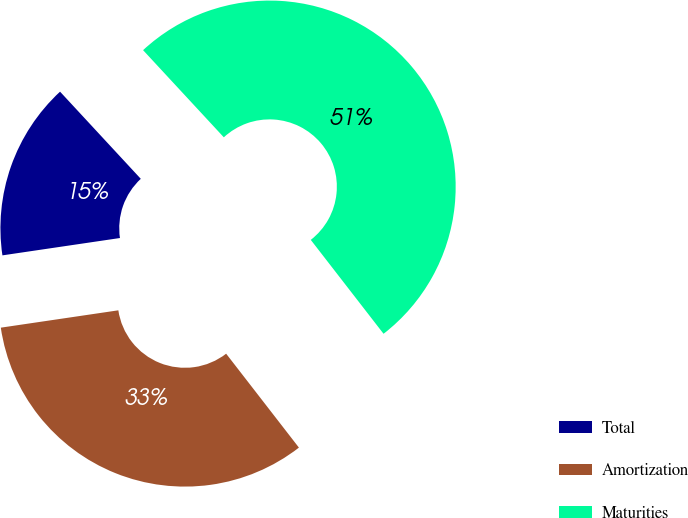<chart> <loc_0><loc_0><loc_500><loc_500><pie_chart><fcel>Total<fcel>Amortization<fcel>Maturities<nl><fcel>15.44%<fcel>33.16%<fcel>51.4%<nl></chart> 